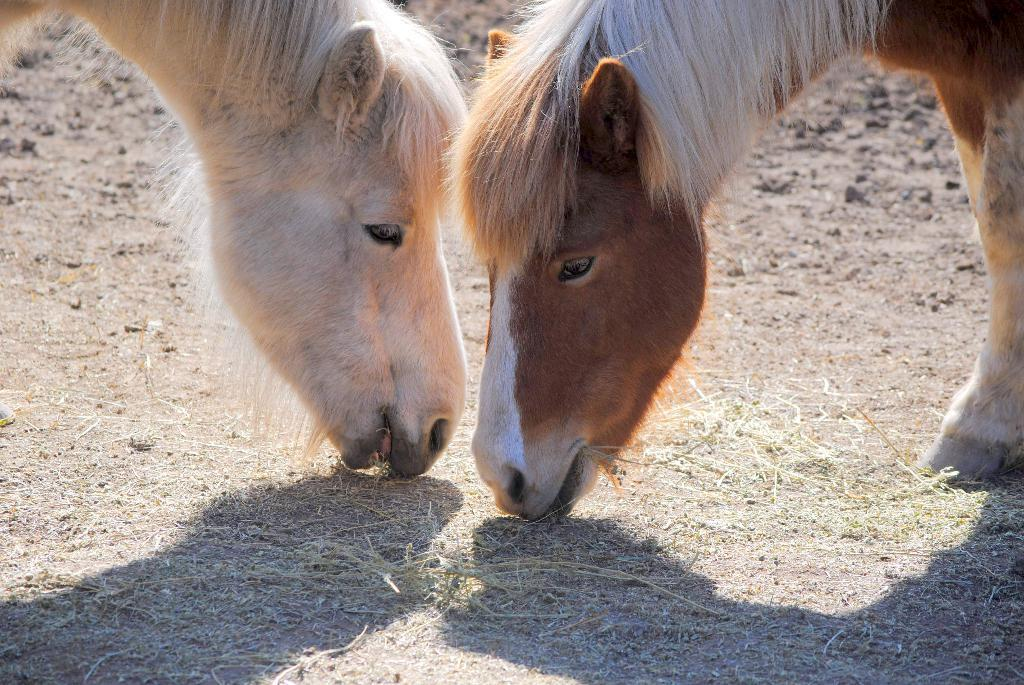How many animals are present in the image? There are two animals in the image. What are the animals doing in the image? The animals are eating grass. Can you describe the color of the animals? The animals are in brown and white color. What type of oatmeal is being served in the image? There is no oatmeal present in the image; it features two animals eating grass. 